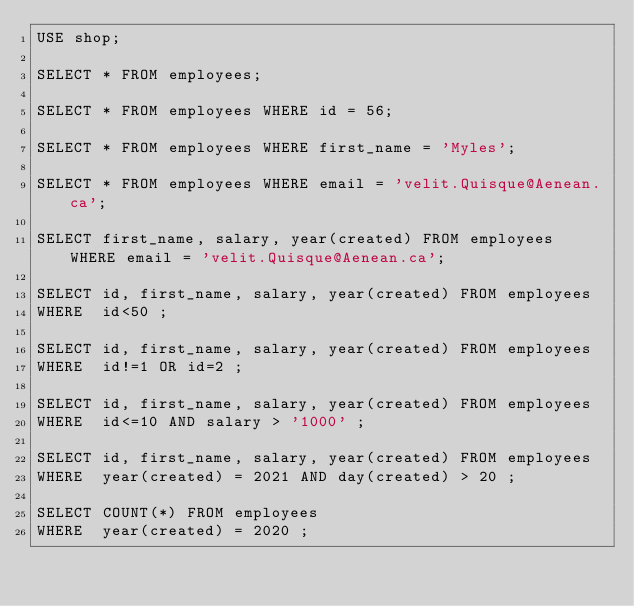Convert code to text. <code><loc_0><loc_0><loc_500><loc_500><_SQL_>USE shop;

SELECT * FROM employees;

SELECT * FROM employees WHERE id = 56;

SELECT * FROM employees WHERE first_name = 'Myles';

SELECT * FROM employees WHERE email = 'velit.Quisque@Aenean.ca';

SELECT first_name, salary, year(created) FROM employees WHERE email = 'velit.Quisque@Aenean.ca';

SELECT id, first_name, salary, year(created) FROM employees
WHERE  id<50 ;

SELECT id, first_name, salary, year(created) FROM employees
WHERE  id!=1 OR id=2 ;

SELECT id, first_name, salary, year(created) FROM employees
WHERE  id<=10 AND salary > '1000' ;

SELECT id, first_name, salary, year(created) FROM employees
WHERE  year(created) = 2021 AND day(created) > 20 ;

SELECT COUNT(*) FROM employees
WHERE  year(created) = 2020 ;

</code> 